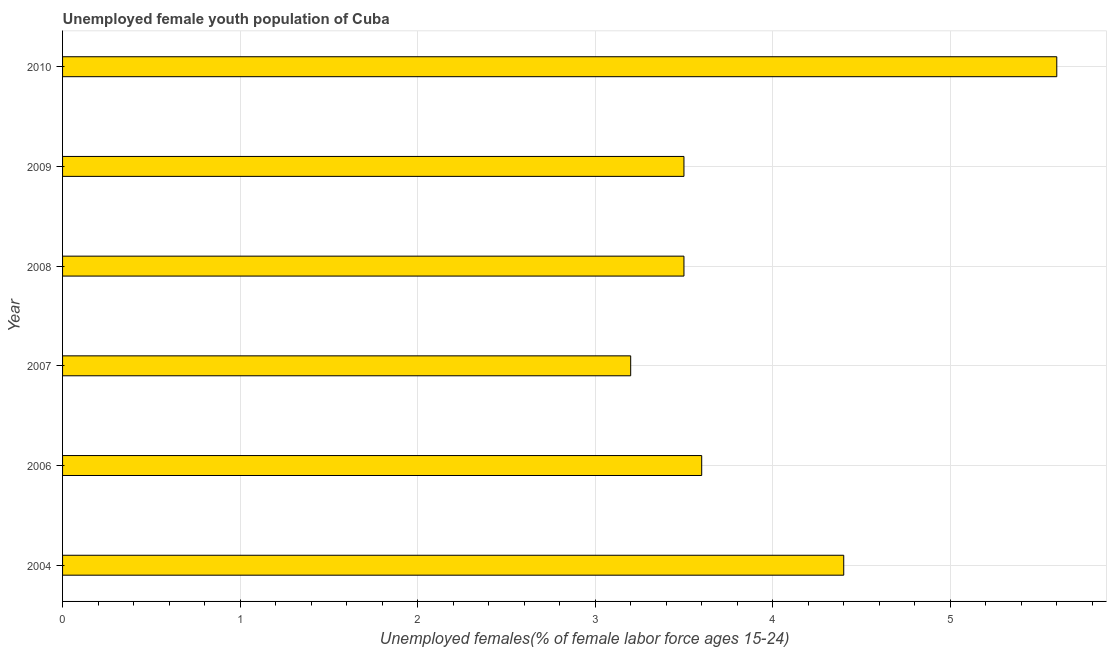What is the title of the graph?
Offer a very short reply. Unemployed female youth population of Cuba. What is the label or title of the X-axis?
Your response must be concise. Unemployed females(% of female labor force ages 15-24). What is the unemployed female youth in 2006?
Make the answer very short. 3.6. Across all years, what is the maximum unemployed female youth?
Offer a very short reply. 5.6. Across all years, what is the minimum unemployed female youth?
Keep it short and to the point. 3.2. In which year was the unemployed female youth minimum?
Provide a succinct answer. 2007. What is the sum of the unemployed female youth?
Provide a succinct answer. 23.8. What is the difference between the unemployed female youth in 2006 and 2009?
Your answer should be compact. 0.1. What is the average unemployed female youth per year?
Your response must be concise. 3.97. What is the median unemployed female youth?
Your answer should be very brief. 3.55. In how many years, is the unemployed female youth greater than 1.6 %?
Offer a very short reply. 6. What is the ratio of the unemployed female youth in 2007 to that in 2010?
Offer a very short reply. 0.57. Is the difference between the unemployed female youth in 2004 and 2006 greater than the difference between any two years?
Offer a very short reply. No. What is the difference between the highest and the second highest unemployed female youth?
Offer a terse response. 1.2. Is the sum of the unemployed female youth in 2007 and 2010 greater than the maximum unemployed female youth across all years?
Provide a short and direct response. Yes. How many bars are there?
Your response must be concise. 6. Are all the bars in the graph horizontal?
Your answer should be very brief. Yes. How many years are there in the graph?
Give a very brief answer. 6. What is the difference between two consecutive major ticks on the X-axis?
Offer a very short reply. 1. Are the values on the major ticks of X-axis written in scientific E-notation?
Provide a succinct answer. No. What is the Unemployed females(% of female labor force ages 15-24) of 2004?
Your answer should be compact. 4.4. What is the Unemployed females(% of female labor force ages 15-24) of 2006?
Provide a succinct answer. 3.6. What is the Unemployed females(% of female labor force ages 15-24) in 2007?
Keep it short and to the point. 3.2. What is the Unemployed females(% of female labor force ages 15-24) of 2010?
Provide a succinct answer. 5.6. What is the difference between the Unemployed females(% of female labor force ages 15-24) in 2004 and 2007?
Your answer should be compact. 1.2. What is the difference between the Unemployed females(% of female labor force ages 15-24) in 2004 and 2008?
Offer a terse response. 0.9. What is the difference between the Unemployed females(% of female labor force ages 15-24) in 2004 and 2009?
Offer a terse response. 0.9. What is the difference between the Unemployed females(% of female labor force ages 15-24) in 2006 and 2007?
Your answer should be compact. 0.4. What is the difference between the Unemployed females(% of female labor force ages 15-24) in 2006 and 2008?
Your response must be concise. 0.1. What is the difference between the Unemployed females(% of female labor force ages 15-24) in 2006 and 2009?
Your answer should be very brief. 0.1. What is the difference between the Unemployed females(% of female labor force ages 15-24) in 2007 and 2008?
Your response must be concise. -0.3. What is the difference between the Unemployed females(% of female labor force ages 15-24) in 2007 and 2009?
Keep it short and to the point. -0.3. What is the difference between the Unemployed females(% of female labor force ages 15-24) in 2009 and 2010?
Your answer should be very brief. -2.1. What is the ratio of the Unemployed females(% of female labor force ages 15-24) in 2004 to that in 2006?
Your answer should be compact. 1.22. What is the ratio of the Unemployed females(% of female labor force ages 15-24) in 2004 to that in 2007?
Ensure brevity in your answer.  1.38. What is the ratio of the Unemployed females(% of female labor force ages 15-24) in 2004 to that in 2008?
Keep it short and to the point. 1.26. What is the ratio of the Unemployed females(% of female labor force ages 15-24) in 2004 to that in 2009?
Offer a terse response. 1.26. What is the ratio of the Unemployed females(% of female labor force ages 15-24) in 2004 to that in 2010?
Your response must be concise. 0.79. What is the ratio of the Unemployed females(% of female labor force ages 15-24) in 2006 to that in 2007?
Provide a short and direct response. 1.12. What is the ratio of the Unemployed females(% of female labor force ages 15-24) in 2006 to that in 2008?
Offer a terse response. 1.03. What is the ratio of the Unemployed females(% of female labor force ages 15-24) in 2006 to that in 2009?
Your response must be concise. 1.03. What is the ratio of the Unemployed females(% of female labor force ages 15-24) in 2006 to that in 2010?
Keep it short and to the point. 0.64. What is the ratio of the Unemployed females(% of female labor force ages 15-24) in 2007 to that in 2008?
Offer a terse response. 0.91. What is the ratio of the Unemployed females(% of female labor force ages 15-24) in 2007 to that in 2009?
Your response must be concise. 0.91. What is the ratio of the Unemployed females(% of female labor force ages 15-24) in 2007 to that in 2010?
Provide a short and direct response. 0.57. What is the ratio of the Unemployed females(% of female labor force ages 15-24) in 2008 to that in 2010?
Provide a short and direct response. 0.62. 